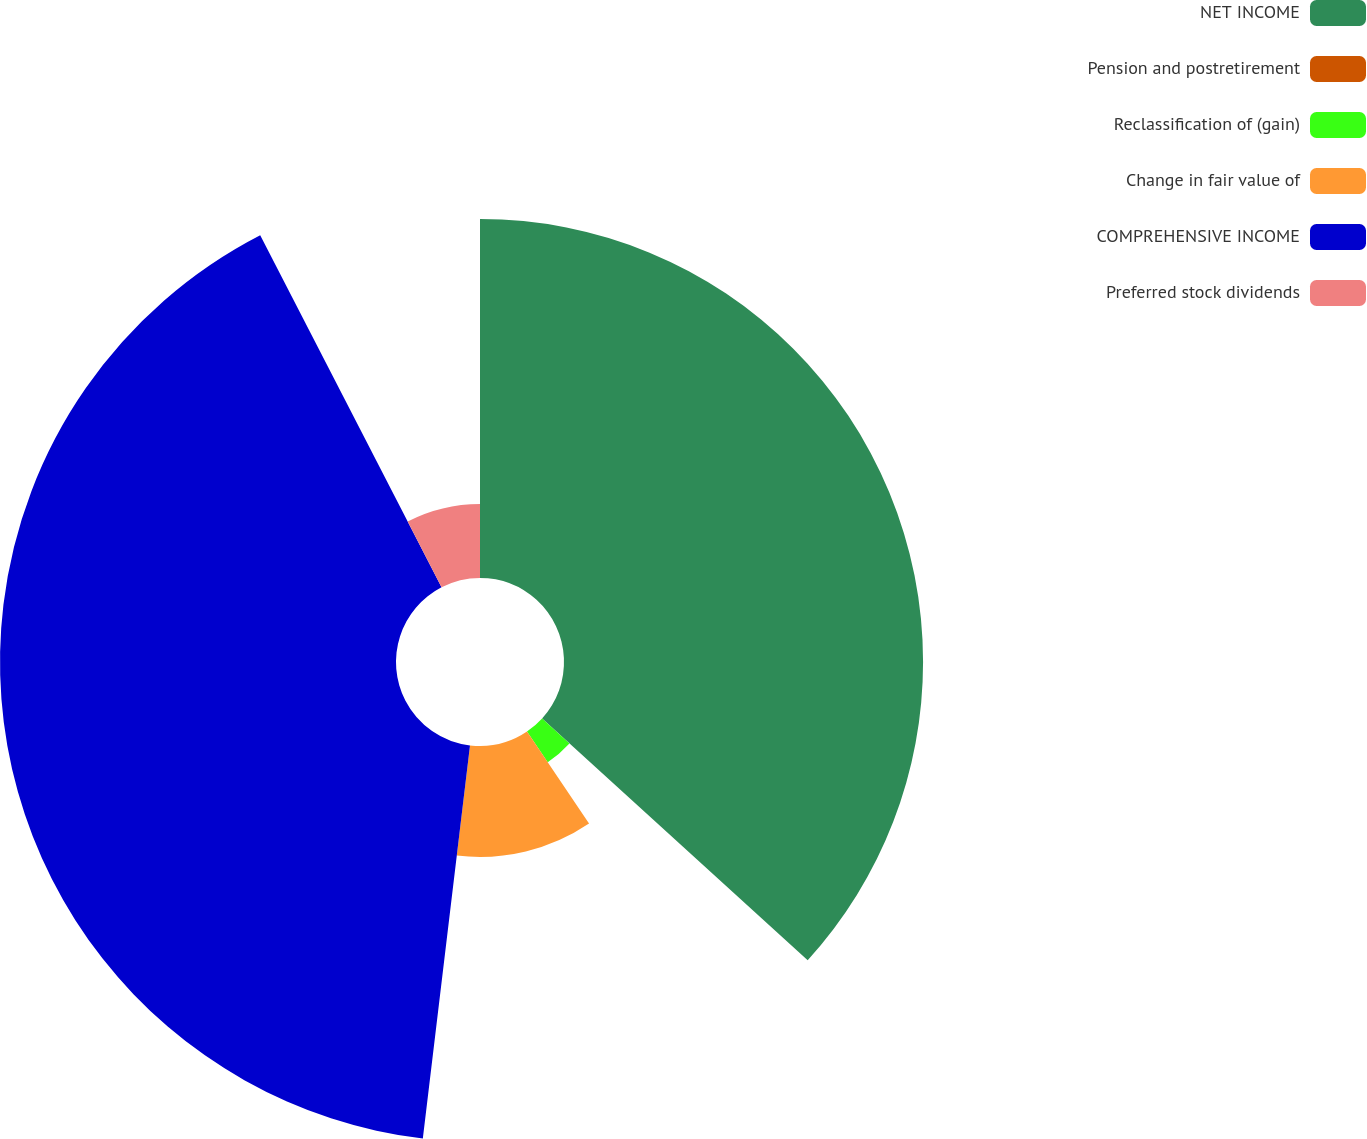Convert chart. <chart><loc_0><loc_0><loc_500><loc_500><pie_chart><fcel>NET INCOME<fcel>Pension and postretirement<fcel>Reclassification of (gain)<fcel>Change in fair value of<fcel>COMPREHENSIVE INCOME<fcel>Preferred stock dividends<nl><fcel>36.75%<fcel>0.01%<fcel>3.79%<fcel>11.35%<fcel>40.53%<fcel>7.57%<nl></chart> 